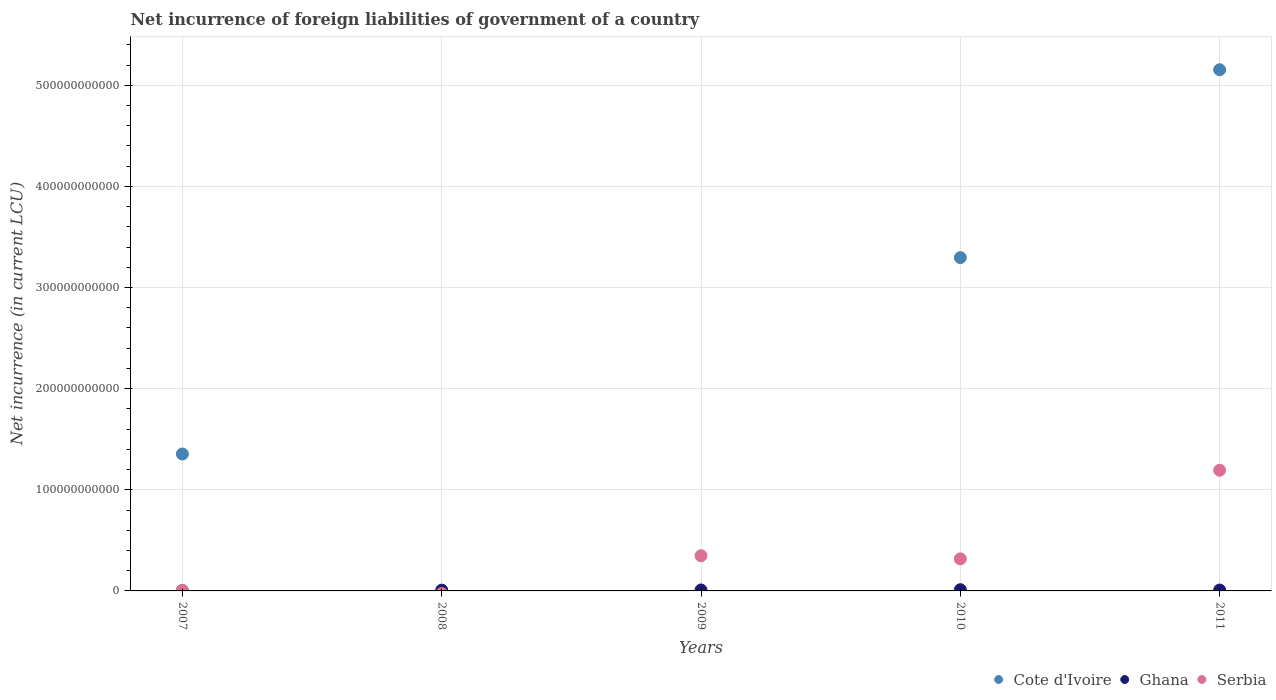Is the number of dotlines equal to the number of legend labels?
Keep it short and to the point. No. What is the net incurrence of foreign liabilities in Ghana in 2008?
Provide a succinct answer. 7.53e+08. Across all years, what is the maximum net incurrence of foreign liabilities in Serbia?
Make the answer very short. 1.19e+11. Across all years, what is the minimum net incurrence of foreign liabilities in Ghana?
Your answer should be compact. 3.27e+08. What is the total net incurrence of foreign liabilities in Cote d'Ivoire in the graph?
Offer a terse response. 9.80e+11. What is the difference between the net incurrence of foreign liabilities in Ghana in 2007 and that in 2010?
Offer a very short reply. -8.81e+08. What is the difference between the net incurrence of foreign liabilities in Serbia in 2011 and the net incurrence of foreign liabilities in Cote d'Ivoire in 2007?
Your answer should be very brief. -1.61e+1. What is the average net incurrence of foreign liabilities in Serbia per year?
Make the answer very short. 3.73e+1. In the year 2011, what is the difference between the net incurrence of foreign liabilities in Cote d'Ivoire and net incurrence of foreign liabilities in Serbia?
Ensure brevity in your answer.  3.96e+11. What is the ratio of the net incurrence of foreign liabilities in Ghana in 2008 to that in 2010?
Provide a succinct answer. 0.62. Is the net incurrence of foreign liabilities in Serbia in 2007 less than that in 2011?
Your answer should be compact. Yes. Is the difference between the net incurrence of foreign liabilities in Cote d'Ivoire in 2007 and 2010 greater than the difference between the net incurrence of foreign liabilities in Serbia in 2007 and 2010?
Make the answer very short. No. What is the difference between the highest and the second highest net incurrence of foreign liabilities in Serbia?
Provide a succinct answer. 8.45e+1. What is the difference between the highest and the lowest net incurrence of foreign liabilities in Ghana?
Offer a terse response. 8.81e+08. In how many years, is the net incurrence of foreign liabilities in Ghana greater than the average net incurrence of foreign liabilities in Ghana taken over all years?
Your response must be concise. 3. Is the sum of the net incurrence of foreign liabilities in Ghana in 2010 and 2011 greater than the maximum net incurrence of foreign liabilities in Serbia across all years?
Offer a terse response. No. Is the net incurrence of foreign liabilities in Serbia strictly greater than the net incurrence of foreign liabilities in Cote d'Ivoire over the years?
Your answer should be very brief. No. Is the net incurrence of foreign liabilities in Cote d'Ivoire strictly less than the net incurrence of foreign liabilities in Serbia over the years?
Your answer should be compact. No. What is the difference between two consecutive major ticks on the Y-axis?
Your response must be concise. 1.00e+11. Are the values on the major ticks of Y-axis written in scientific E-notation?
Your answer should be compact. No. Does the graph contain any zero values?
Make the answer very short. Yes. Where does the legend appear in the graph?
Offer a terse response. Bottom right. How are the legend labels stacked?
Your response must be concise. Horizontal. What is the title of the graph?
Provide a succinct answer. Net incurrence of foreign liabilities of government of a country. Does "Guatemala" appear as one of the legend labels in the graph?
Ensure brevity in your answer.  No. What is the label or title of the Y-axis?
Your response must be concise. Net incurrence (in current LCU). What is the Net incurrence (in current LCU) in Cote d'Ivoire in 2007?
Offer a very short reply. 1.35e+11. What is the Net incurrence (in current LCU) in Ghana in 2007?
Give a very brief answer. 3.27e+08. What is the Net incurrence (in current LCU) in Serbia in 2007?
Provide a succinct answer. 5.15e+08. What is the Net incurrence (in current LCU) of Cote d'Ivoire in 2008?
Offer a terse response. 0. What is the Net incurrence (in current LCU) of Ghana in 2008?
Provide a short and direct response. 7.53e+08. What is the Net incurrence (in current LCU) in Serbia in 2008?
Your answer should be very brief. 0. What is the Net incurrence (in current LCU) of Ghana in 2009?
Your response must be concise. 9.56e+08. What is the Net incurrence (in current LCU) of Serbia in 2009?
Provide a short and direct response. 3.48e+1. What is the Net incurrence (in current LCU) of Cote d'Ivoire in 2010?
Your answer should be very brief. 3.30e+11. What is the Net incurrence (in current LCU) in Ghana in 2010?
Provide a succinct answer. 1.21e+09. What is the Net incurrence (in current LCU) in Serbia in 2010?
Give a very brief answer. 3.17e+1. What is the Net incurrence (in current LCU) in Cote d'Ivoire in 2011?
Provide a short and direct response. 5.15e+11. What is the Net incurrence (in current LCU) of Ghana in 2011?
Provide a short and direct response. 8.56e+08. What is the Net incurrence (in current LCU) in Serbia in 2011?
Your answer should be compact. 1.19e+11. Across all years, what is the maximum Net incurrence (in current LCU) of Cote d'Ivoire?
Provide a short and direct response. 5.15e+11. Across all years, what is the maximum Net incurrence (in current LCU) of Ghana?
Ensure brevity in your answer.  1.21e+09. Across all years, what is the maximum Net incurrence (in current LCU) of Serbia?
Offer a very short reply. 1.19e+11. Across all years, what is the minimum Net incurrence (in current LCU) of Cote d'Ivoire?
Keep it short and to the point. 0. Across all years, what is the minimum Net incurrence (in current LCU) in Ghana?
Keep it short and to the point. 3.27e+08. What is the total Net incurrence (in current LCU) in Cote d'Ivoire in the graph?
Keep it short and to the point. 9.80e+11. What is the total Net incurrence (in current LCU) of Ghana in the graph?
Offer a very short reply. 4.10e+09. What is the total Net incurrence (in current LCU) of Serbia in the graph?
Offer a terse response. 1.86e+11. What is the difference between the Net incurrence (in current LCU) of Ghana in 2007 and that in 2008?
Make the answer very short. -4.25e+08. What is the difference between the Net incurrence (in current LCU) of Ghana in 2007 and that in 2009?
Provide a succinct answer. -6.28e+08. What is the difference between the Net incurrence (in current LCU) in Serbia in 2007 and that in 2009?
Your response must be concise. -3.43e+1. What is the difference between the Net incurrence (in current LCU) of Cote d'Ivoire in 2007 and that in 2010?
Make the answer very short. -1.94e+11. What is the difference between the Net incurrence (in current LCU) in Ghana in 2007 and that in 2010?
Make the answer very short. -8.81e+08. What is the difference between the Net incurrence (in current LCU) of Serbia in 2007 and that in 2010?
Provide a succinct answer. -3.12e+1. What is the difference between the Net incurrence (in current LCU) in Cote d'Ivoire in 2007 and that in 2011?
Provide a succinct answer. -3.80e+11. What is the difference between the Net incurrence (in current LCU) of Ghana in 2007 and that in 2011?
Offer a very short reply. -5.29e+08. What is the difference between the Net incurrence (in current LCU) in Serbia in 2007 and that in 2011?
Offer a very short reply. -1.19e+11. What is the difference between the Net incurrence (in current LCU) of Ghana in 2008 and that in 2009?
Offer a terse response. -2.03e+08. What is the difference between the Net incurrence (in current LCU) in Ghana in 2008 and that in 2010?
Provide a short and direct response. -4.56e+08. What is the difference between the Net incurrence (in current LCU) of Ghana in 2008 and that in 2011?
Ensure brevity in your answer.  -1.04e+08. What is the difference between the Net incurrence (in current LCU) in Ghana in 2009 and that in 2010?
Your answer should be compact. -2.53e+08. What is the difference between the Net incurrence (in current LCU) of Serbia in 2009 and that in 2010?
Provide a succinct answer. 3.08e+09. What is the difference between the Net incurrence (in current LCU) in Ghana in 2009 and that in 2011?
Your response must be concise. 9.93e+07. What is the difference between the Net incurrence (in current LCU) in Serbia in 2009 and that in 2011?
Provide a succinct answer. -8.45e+1. What is the difference between the Net incurrence (in current LCU) of Cote d'Ivoire in 2010 and that in 2011?
Offer a terse response. -1.86e+11. What is the difference between the Net incurrence (in current LCU) of Ghana in 2010 and that in 2011?
Your answer should be compact. 3.53e+08. What is the difference between the Net incurrence (in current LCU) of Serbia in 2010 and that in 2011?
Offer a very short reply. -8.76e+1. What is the difference between the Net incurrence (in current LCU) of Cote d'Ivoire in 2007 and the Net incurrence (in current LCU) of Ghana in 2008?
Your response must be concise. 1.35e+11. What is the difference between the Net incurrence (in current LCU) in Cote d'Ivoire in 2007 and the Net incurrence (in current LCU) in Ghana in 2009?
Keep it short and to the point. 1.34e+11. What is the difference between the Net incurrence (in current LCU) of Cote d'Ivoire in 2007 and the Net incurrence (in current LCU) of Serbia in 2009?
Make the answer very short. 1.01e+11. What is the difference between the Net incurrence (in current LCU) of Ghana in 2007 and the Net incurrence (in current LCU) of Serbia in 2009?
Give a very brief answer. -3.45e+1. What is the difference between the Net incurrence (in current LCU) of Cote d'Ivoire in 2007 and the Net incurrence (in current LCU) of Ghana in 2010?
Make the answer very short. 1.34e+11. What is the difference between the Net incurrence (in current LCU) of Cote d'Ivoire in 2007 and the Net incurrence (in current LCU) of Serbia in 2010?
Provide a short and direct response. 1.04e+11. What is the difference between the Net incurrence (in current LCU) in Ghana in 2007 and the Net incurrence (in current LCU) in Serbia in 2010?
Keep it short and to the point. -3.14e+1. What is the difference between the Net incurrence (in current LCU) of Cote d'Ivoire in 2007 and the Net incurrence (in current LCU) of Ghana in 2011?
Your answer should be very brief. 1.35e+11. What is the difference between the Net incurrence (in current LCU) of Cote d'Ivoire in 2007 and the Net incurrence (in current LCU) of Serbia in 2011?
Provide a short and direct response. 1.61e+1. What is the difference between the Net incurrence (in current LCU) in Ghana in 2007 and the Net incurrence (in current LCU) in Serbia in 2011?
Give a very brief answer. -1.19e+11. What is the difference between the Net incurrence (in current LCU) of Ghana in 2008 and the Net incurrence (in current LCU) of Serbia in 2009?
Your answer should be compact. -3.41e+1. What is the difference between the Net incurrence (in current LCU) in Ghana in 2008 and the Net incurrence (in current LCU) in Serbia in 2010?
Keep it short and to the point. -3.10e+1. What is the difference between the Net incurrence (in current LCU) in Ghana in 2008 and the Net incurrence (in current LCU) in Serbia in 2011?
Give a very brief answer. -1.19e+11. What is the difference between the Net incurrence (in current LCU) of Ghana in 2009 and the Net incurrence (in current LCU) of Serbia in 2010?
Keep it short and to the point. -3.08e+1. What is the difference between the Net incurrence (in current LCU) of Ghana in 2009 and the Net incurrence (in current LCU) of Serbia in 2011?
Your answer should be very brief. -1.18e+11. What is the difference between the Net incurrence (in current LCU) in Cote d'Ivoire in 2010 and the Net incurrence (in current LCU) in Ghana in 2011?
Ensure brevity in your answer.  3.29e+11. What is the difference between the Net incurrence (in current LCU) in Cote d'Ivoire in 2010 and the Net incurrence (in current LCU) in Serbia in 2011?
Your answer should be very brief. 2.10e+11. What is the difference between the Net incurrence (in current LCU) in Ghana in 2010 and the Net incurrence (in current LCU) in Serbia in 2011?
Provide a short and direct response. -1.18e+11. What is the average Net incurrence (in current LCU) of Cote d'Ivoire per year?
Keep it short and to the point. 1.96e+11. What is the average Net incurrence (in current LCU) in Ghana per year?
Make the answer very short. 8.20e+08. What is the average Net incurrence (in current LCU) of Serbia per year?
Provide a short and direct response. 3.73e+1. In the year 2007, what is the difference between the Net incurrence (in current LCU) of Cote d'Ivoire and Net incurrence (in current LCU) of Ghana?
Your response must be concise. 1.35e+11. In the year 2007, what is the difference between the Net incurrence (in current LCU) of Cote d'Ivoire and Net incurrence (in current LCU) of Serbia?
Make the answer very short. 1.35e+11. In the year 2007, what is the difference between the Net incurrence (in current LCU) in Ghana and Net incurrence (in current LCU) in Serbia?
Your answer should be very brief. -1.88e+08. In the year 2009, what is the difference between the Net incurrence (in current LCU) in Ghana and Net incurrence (in current LCU) in Serbia?
Offer a very short reply. -3.39e+1. In the year 2010, what is the difference between the Net incurrence (in current LCU) of Cote d'Ivoire and Net incurrence (in current LCU) of Ghana?
Offer a terse response. 3.28e+11. In the year 2010, what is the difference between the Net incurrence (in current LCU) in Cote d'Ivoire and Net incurrence (in current LCU) in Serbia?
Make the answer very short. 2.98e+11. In the year 2010, what is the difference between the Net incurrence (in current LCU) in Ghana and Net incurrence (in current LCU) in Serbia?
Your answer should be compact. -3.05e+1. In the year 2011, what is the difference between the Net incurrence (in current LCU) in Cote d'Ivoire and Net incurrence (in current LCU) in Ghana?
Offer a very short reply. 5.15e+11. In the year 2011, what is the difference between the Net incurrence (in current LCU) in Cote d'Ivoire and Net incurrence (in current LCU) in Serbia?
Your response must be concise. 3.96e+11. In the year 2011, what is the difference between the Net incurrence (in current LCU) of Ghana and Net incurrence (in current LCU) of Serbia?
Your answer should be very brief. -1.18e+11. What is the ratio of the Net incurrence (in current LCU) of Ghana in 2007 to that in 2008?
Your response must be concise. 0.43. What is the ratio of the Net incurrence (in current LCU) of Ghana in 2007 to that in 2009?
Provide a short and direct response. 0.34. What is the ratio of the Net incurrence (in current LCU) of Serbia in 2007 to that in 2009?
Offer a very short reply. 0.01. What is the ratio of the Net incurrence (in current LCU) in Cote d'Ivoire in 2007 to that in 2010?
Your answer should be compact. 0.41. What is the ratio of the Net incurrence (in current LCU) of Ghana in 2007 to that in 2010?
Provide a succinct answer. 0.27. What is the ratio of the Net incurrence (in current LCU) of Serbia in 2007 to that in 2010?
Make the answer very short. 0.02. What is the ratio of the Net incurrence (in current LCU) of Cote d'Ivoire in 2007 to that in 2011?
Provide a short and direct response. 0.26. What is the ratio of the Net incurrence (in current LCU) of Ghana in 2007 to that in 2011?
Your answer should be very brief. 0.38. What is the ratio of the Net incurrence (in current LCU) in Serbia in 2007 to that in 2011?
Your answer should be very brief. 0. What is the ratio of the Net incurrence (in current LCU) in Ghana in 2008 to that in 2009?
Your response must be concise. 0.79. What is the ratio of the Net incurrence (in current LCU) in Ghana in 2008 to that in 2010?
Provide a succinct answer. 0.62. What is the ratio of the Net incurrence (in current LCU) in Ghana in 2008 to that in 2011?
Offer a very short reply. 0.88. What is the ratio of the Net incurrence (in current LCU) of Ghana in 2009 to that in 2010?
Keep it short and to the point. 0.79. What is the ratio of the Net incurrence (in current LCU) in Serbia in 2009 to that in 2010?
Your response must be concise. 1.1. What is the ratio of the Net incurrence (in current LCU) of Ghana in 2009 to that in 2011?
Offer a terse response. 1.12. What is the ratio of the Net incurrence (in current LCU) in Serbia in 2009 to that in 2011?
Offer a terse response. 0.29. What is the ratio of the Net incurrence (in current LCU) in Cote d'Ivoire in 2010 to that in 2011?
Provide a succinct answer. 0.64. What is the ratio of the Net incurrence (in current LCU) of Ghana in 2010 to that in 2011?
Offer a very short reply. 1.41. What is the ratio of the Net incurrence (in current LCU) of Serbia in 2010 to that in 2011?
Offer a terse response. 0.27. What is the difference between the highest and the second highest Net incurrence (in current LCU) of Cote d'Ivoire?
Make the answer very short. 1.86e+11. What is the difference between the highest and the second highest Net incurrence (in current LCU) of Ghana?
Your response must be concise. 2.53e+08. What is the difference between the highest and the second highest Net incurrence (in current LCU) of Serbia?
Your response must be concise. 8.45e+1. What is the difference between the highest and the lowest Net incurrence (in current LCU) of Cote d'Ivoire?
Your answer should be compact. 5.15e+11. What is the difference between the highest and the lowest Net incurrence (in current LCU) in Ghana?
Provide a short and direct response. 8.81e+08. What is the difference between the highest and the lowest Net incurrence (in current LCU) in Serbia?
Offer a very short reply. 1.19e+11. 